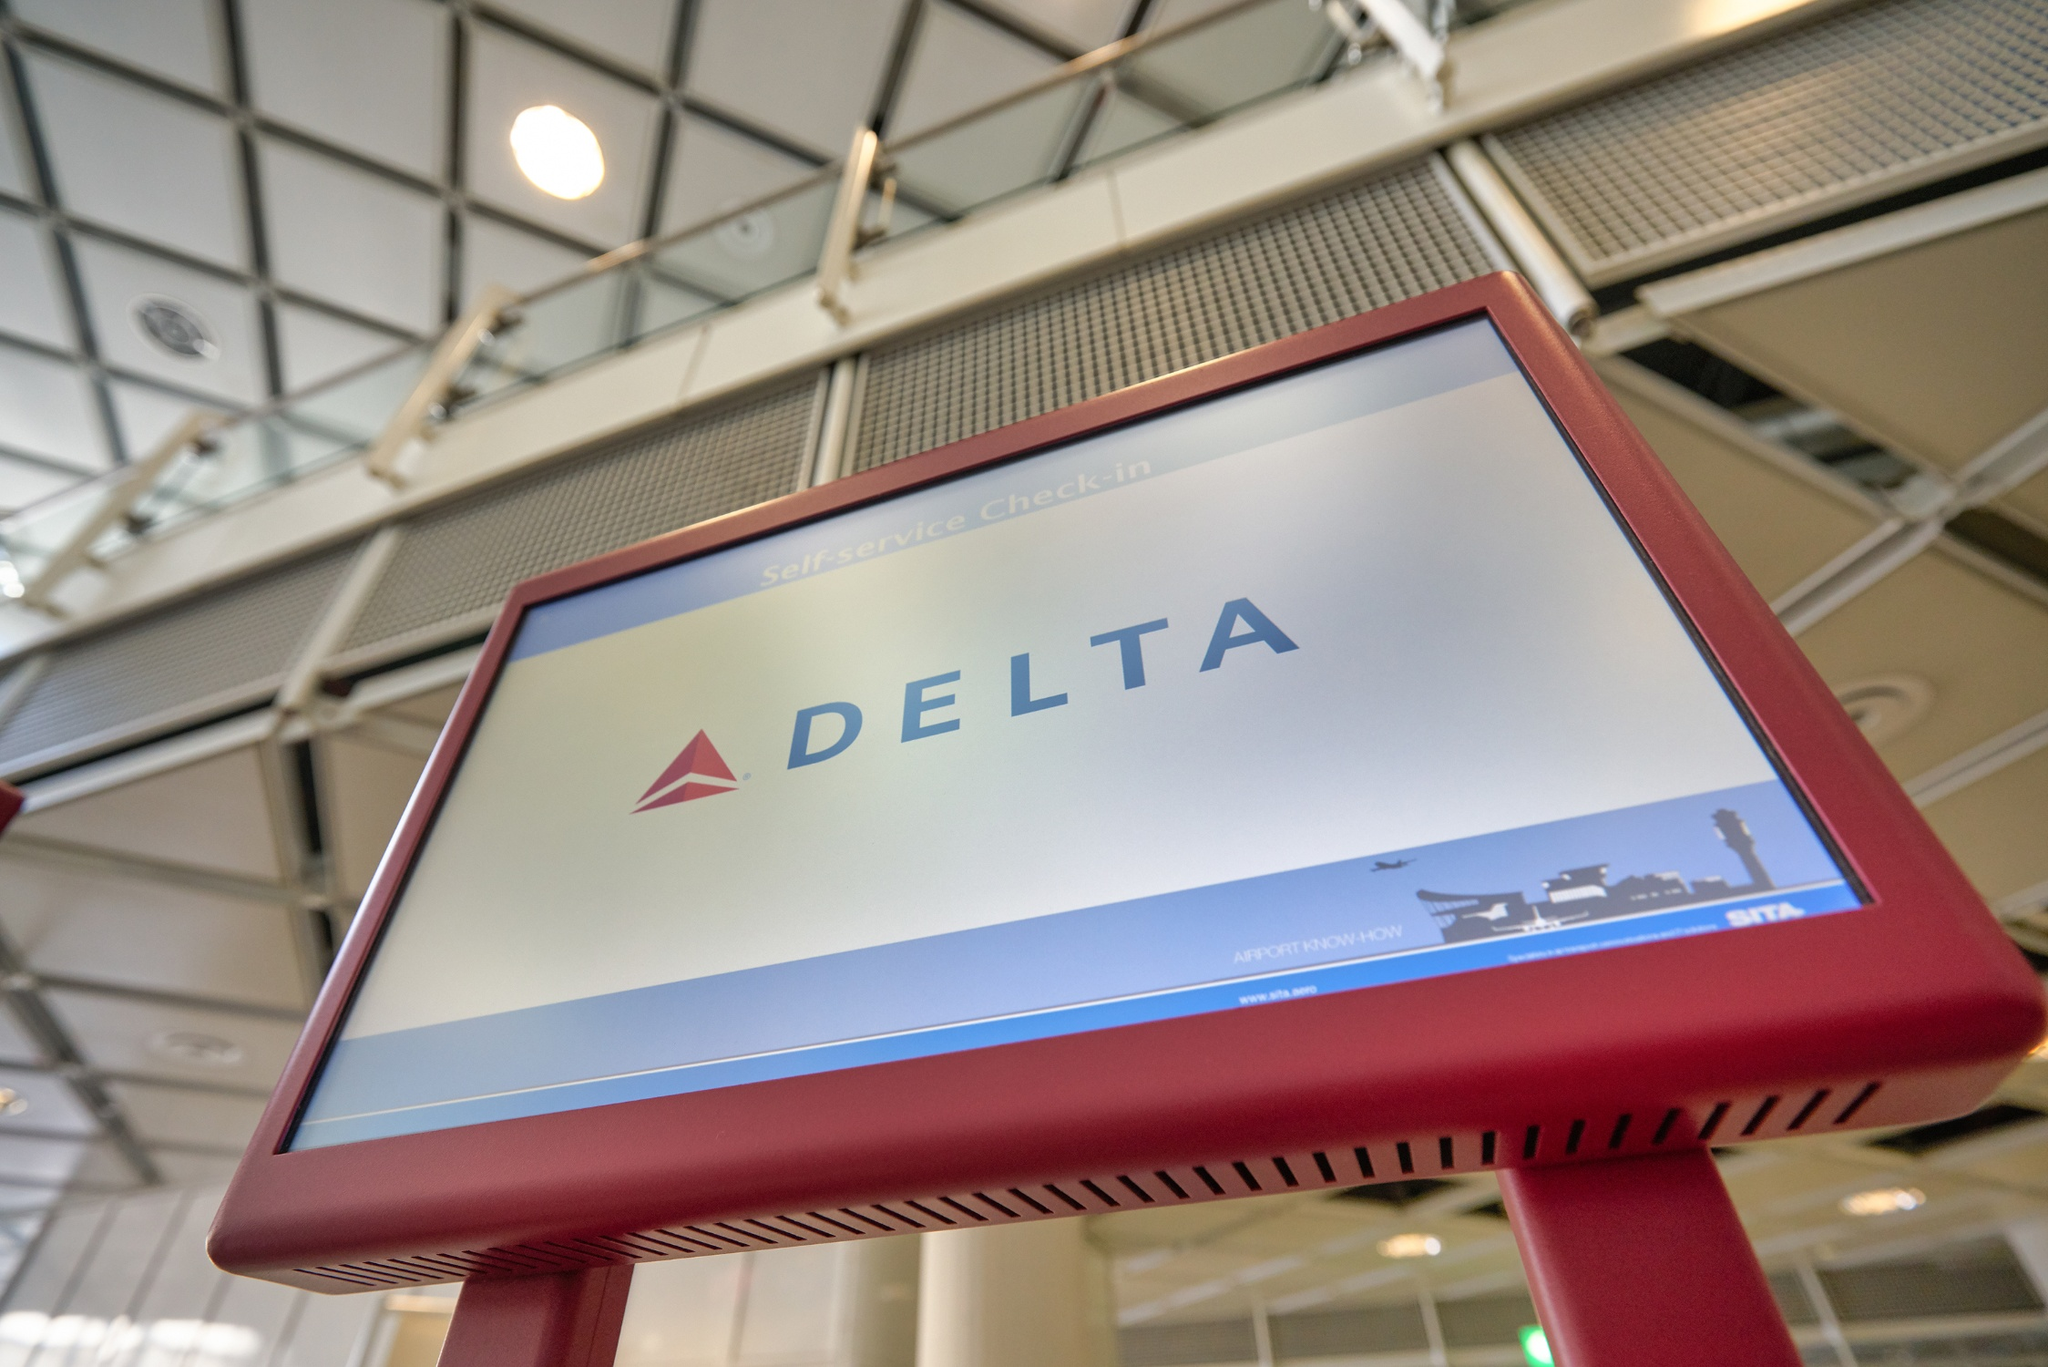What other details can you observe in the terminal environment around the Delta kiosk? The terminal environment around the Delta kiosk appears modern and well-lit, thanks to the extensive use of large windows that let in natural light. The ceiling is high and geometrically patterned, presenting a spacious and airy atmosphere. The polished metal railings and glass barriers further enhance the contemporary aesthetic of the space. This design choice likely aims to make the terminal feel more open and welcoming to travelers. 